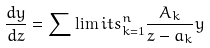Convert formula to latex. <formula><loc_0><loc_0><loc_500><loc_500>\frac { d y } { d z } = \sum \lim i t s _ { k = 1 } ^ { n } \frac { A _ { k } } { z - a _ { k } } y</formula> 